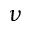Convert formula to latex. <formula><loc_0><loc_0><loc_500><loc_500>\nu</formula> 